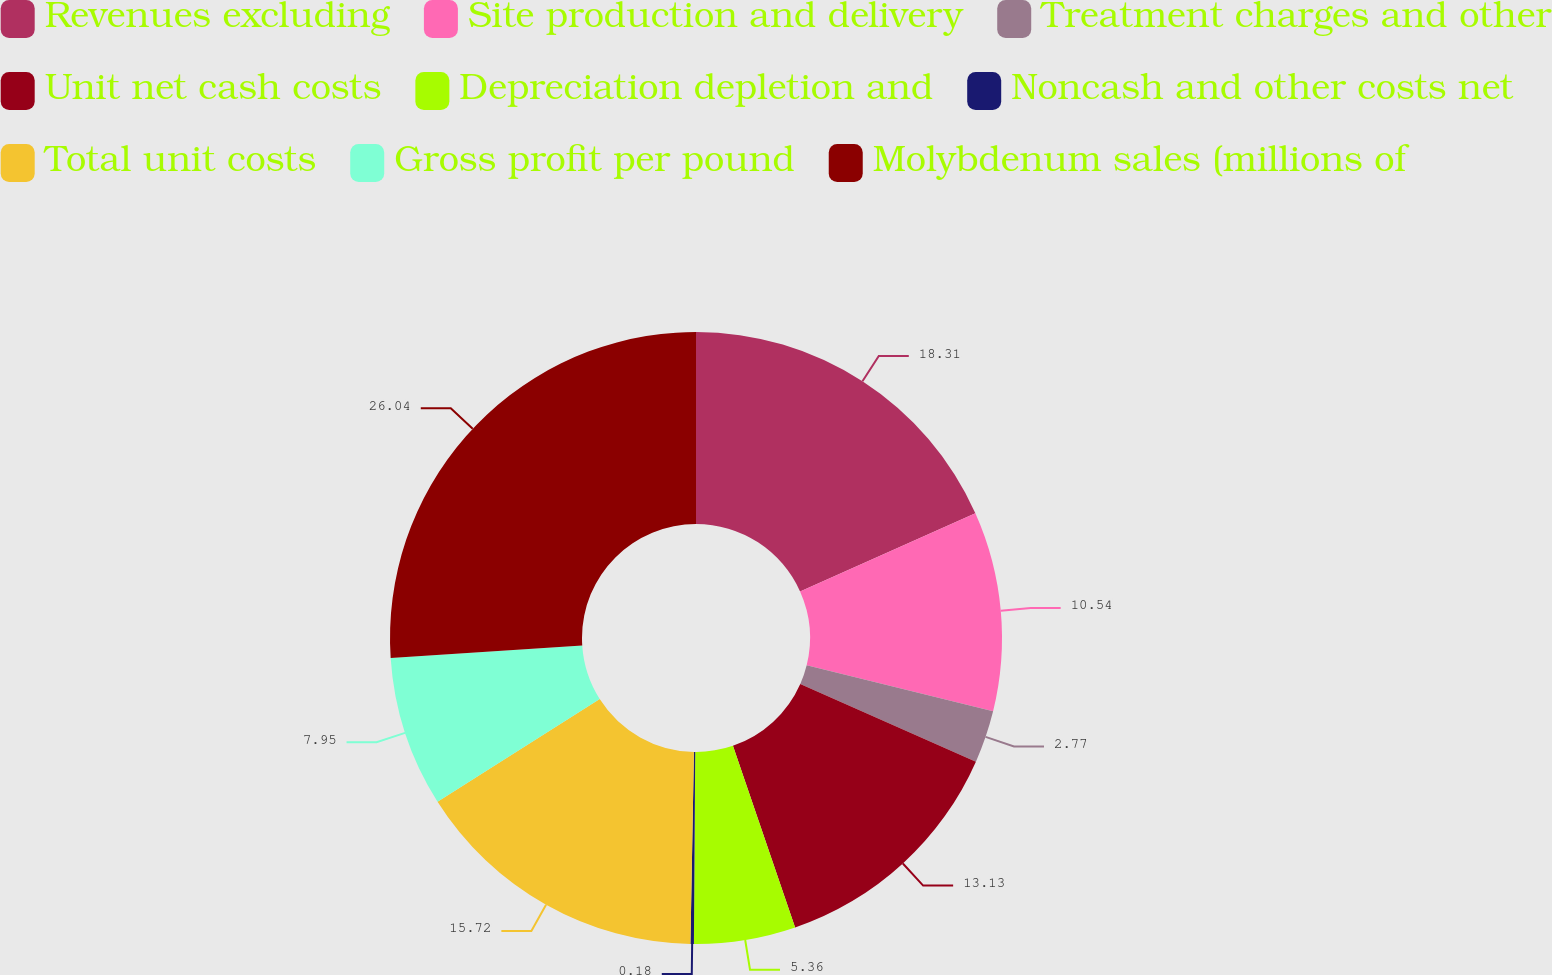<chart> <loc_0><loc_0><loc_500><loc_500><pie_chart><fcel>Revenues excluding<fcel>Site production and delivery<fcel>Treatment charges and other<fcel>Unit net cash costs<fcel>Depreciation depletion and<fcel>Noncash and other costs net<fcel>Total unit costs<fcel>Gross profit per pound<fcel>Molybdenum sales (millions of<nl><fcel>18.31%<fcel>10.54%<fcel>2.77%<fcel>13.13%<fcel>5.36%<fcel>0.18%<fcel>15.72%<fcel>7.95%<fcel>26.04%<nl></chart> 